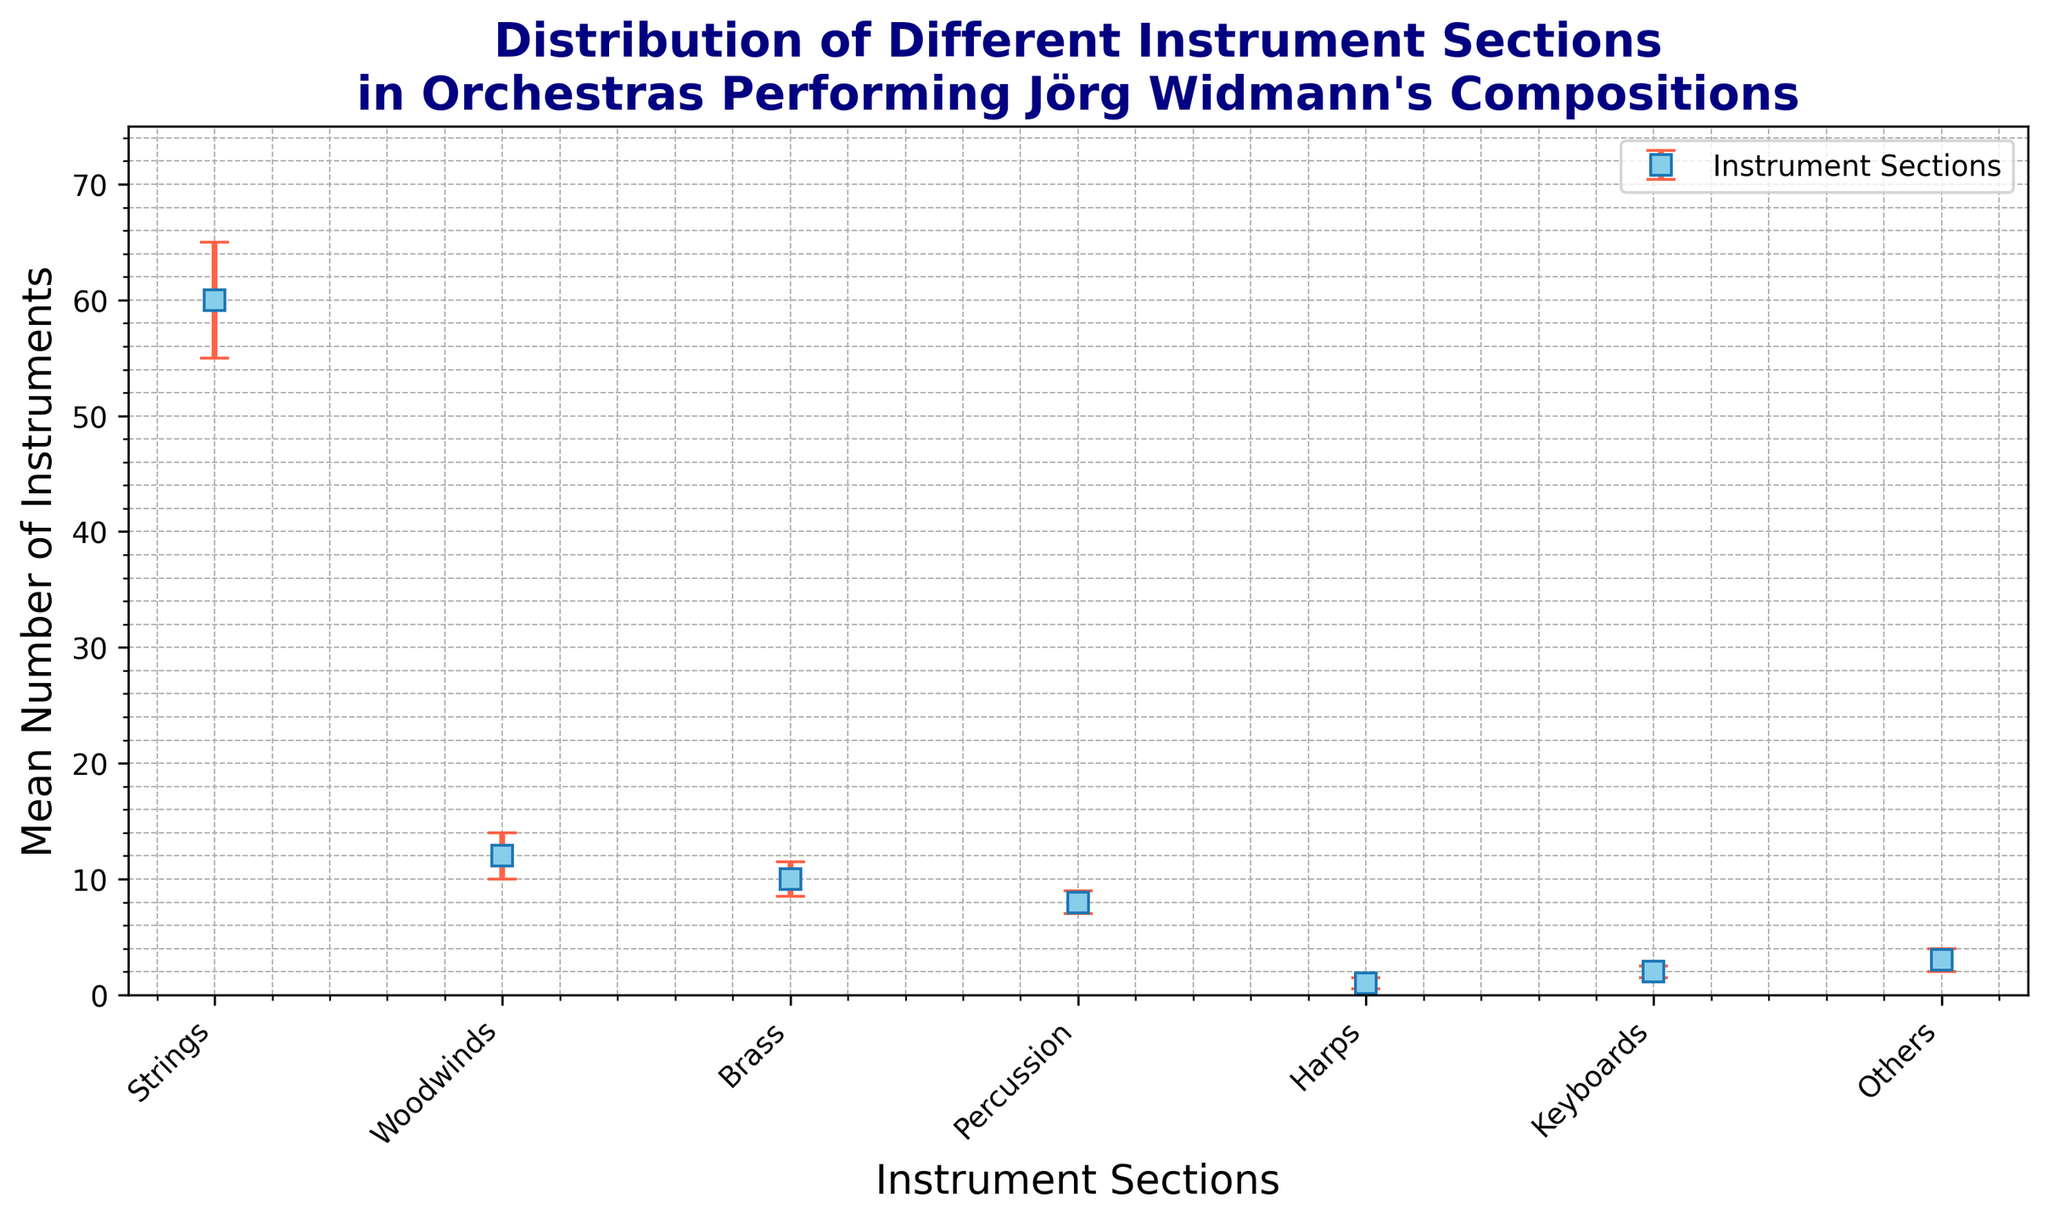What is the mean number of percussion instruments? Look at the data point associated with percussion instruments on the plot and locate its mean value.
Answer: 8 What section has the highest mean value? Observe the plot and identify the section with the tallest marker.
Answer: Strings Which sections have a standard deviation greater than or equal to 1? Examine the error bars for each section, focusing on the ones with larger error bars and check those that exceed 1.
Answer: Strings, Woodwinds, Brass, Others What is the sum of the mean values of Brass and Percussion sections? Fetch the mean values of Brass and Percussion sections (10 and 8, respectively) and add them together.
Answer: 18 How much higher is the mean number of String instruments compared to Woodwinds? Subtract the mean value of Woodwinds (12) from the mean value of Strings (60).
Answer: 48 Which section has the smallest error bar? Look for the section with the shortest error bar on the plot.
Answer: Harps By how much does the mean value of Keyboards differ from Harps? Subtract the mean value of Harps (1) from the mean value of Keyboards (2).
Answer: 1 What is the average of the mean values across all sections? Sum all the mean values (60 + 12 + 10 + 8 + 1 + 2 + 3 = 96) and divide by the number of sections (7).
Answer: 13.71 Which section has a mean value closest to 10? Determine the sections with mean values near 10 and identify the one closest to this value.
Answer: Brass 